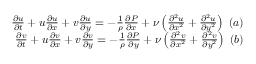Convert formula to latex. <formula><loc_0><loc_0><loc_500><loc_500>\begin{array} { r } { \frac { \partial u } { \partial t } + u \frac { \partial u } { \partial x } + v \frac { \partial u } { \partial y } = - \frac { 1 } { \rho } \frac { \partial P } { \partial x } + \nu \left ( { \frac { \partial ^ { 2 } u } { \partial x ^ { 2 } } + \frac { \partial ^ { 2 } u } { \partial y ^ { 2 } } } \right ) ( a ) } \\ { \frac { \partial v } { \partial t } + u \frac { \partial v } { \partial x } + v \frac { \partial v } { \partial y } = - \frac { 1 } { \rho } \frac { \partial P } { \partial y } + \nu \left ( { \frac { \partial ^ { 2 } v } { \partial x ^ { 2 } } + \frac { \partial ^ { 2 } v } { \partial y ^ { 2 } } } \right ) ( b ) } \end{array}</formula> 